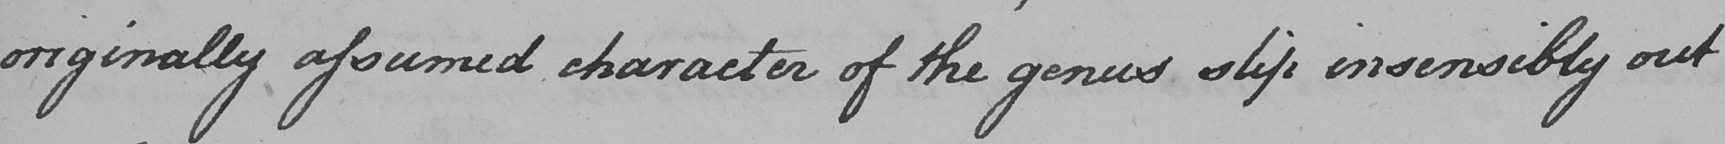What does this handwritten line say? originally assumed character of the genus slip insensibly out 